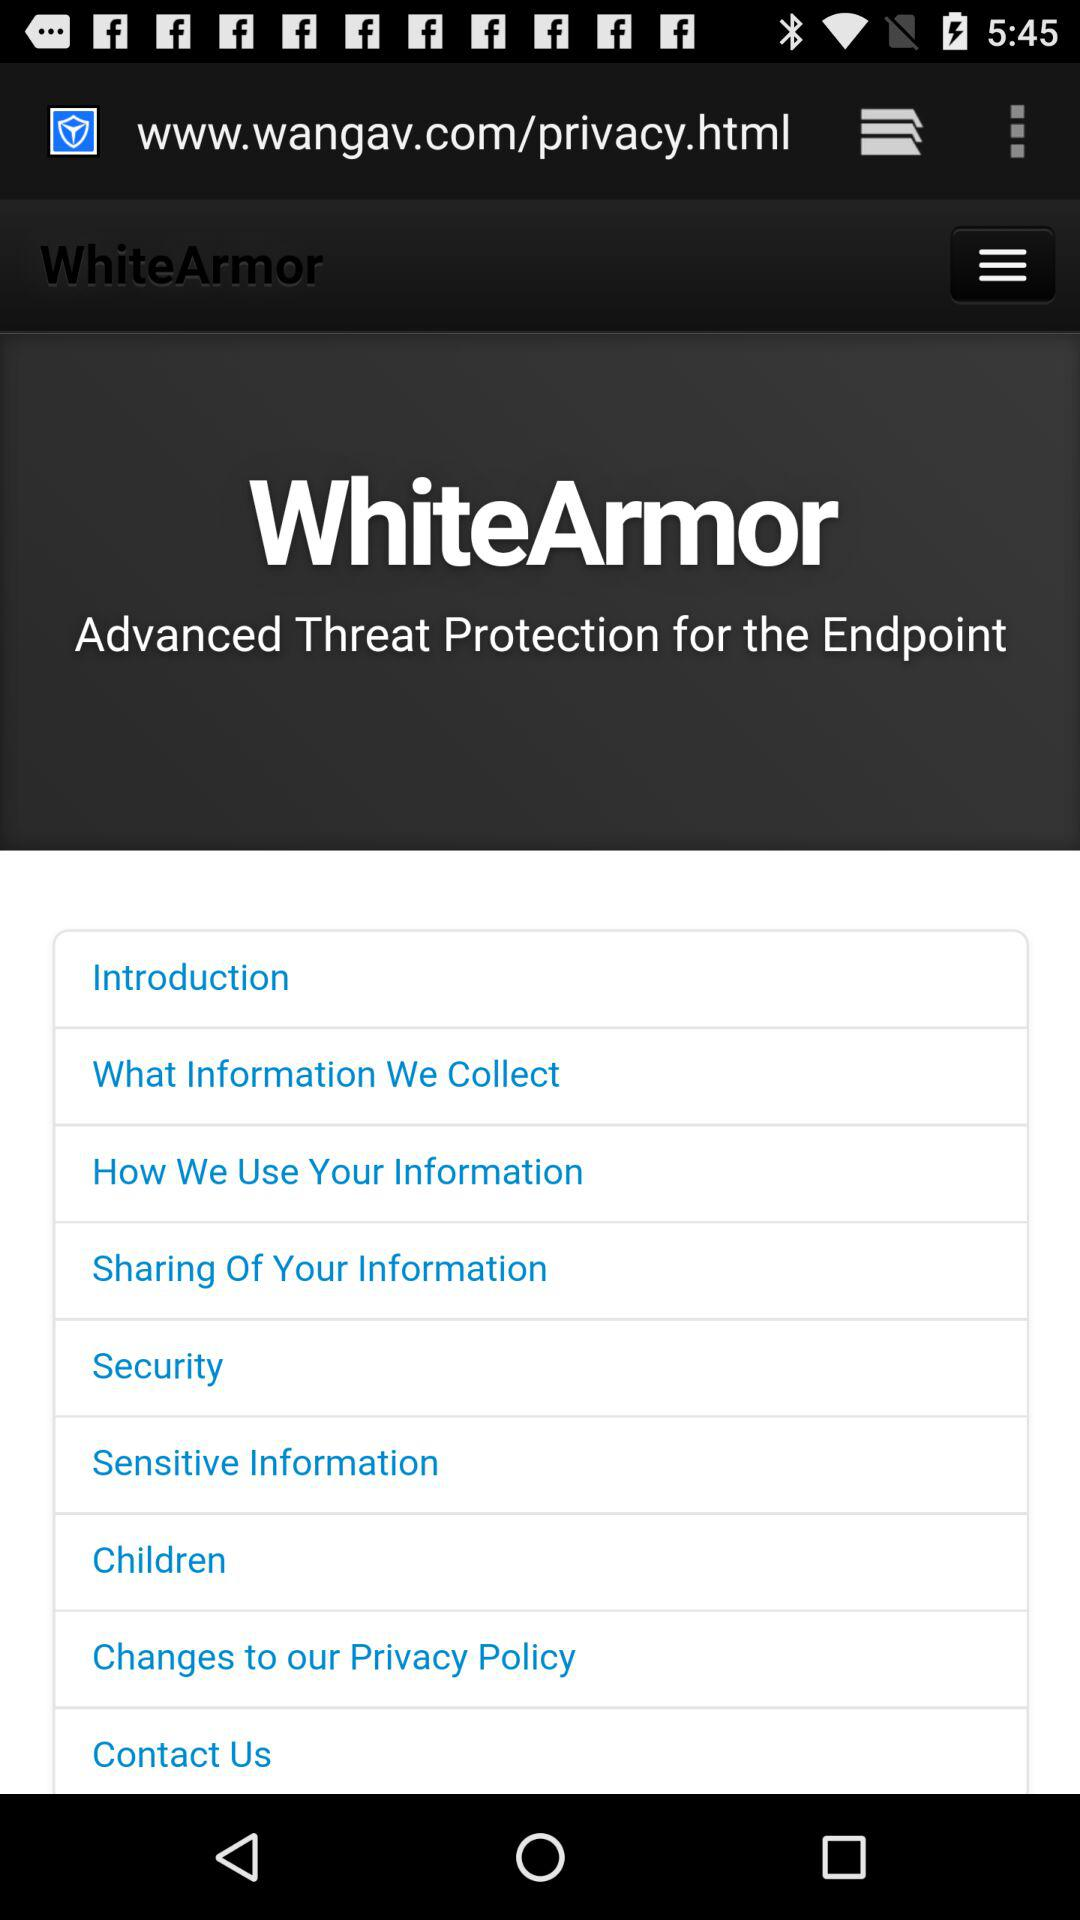What is the application Name?
When the provided information is insufficient, respond with <no answer>. <no answer> 